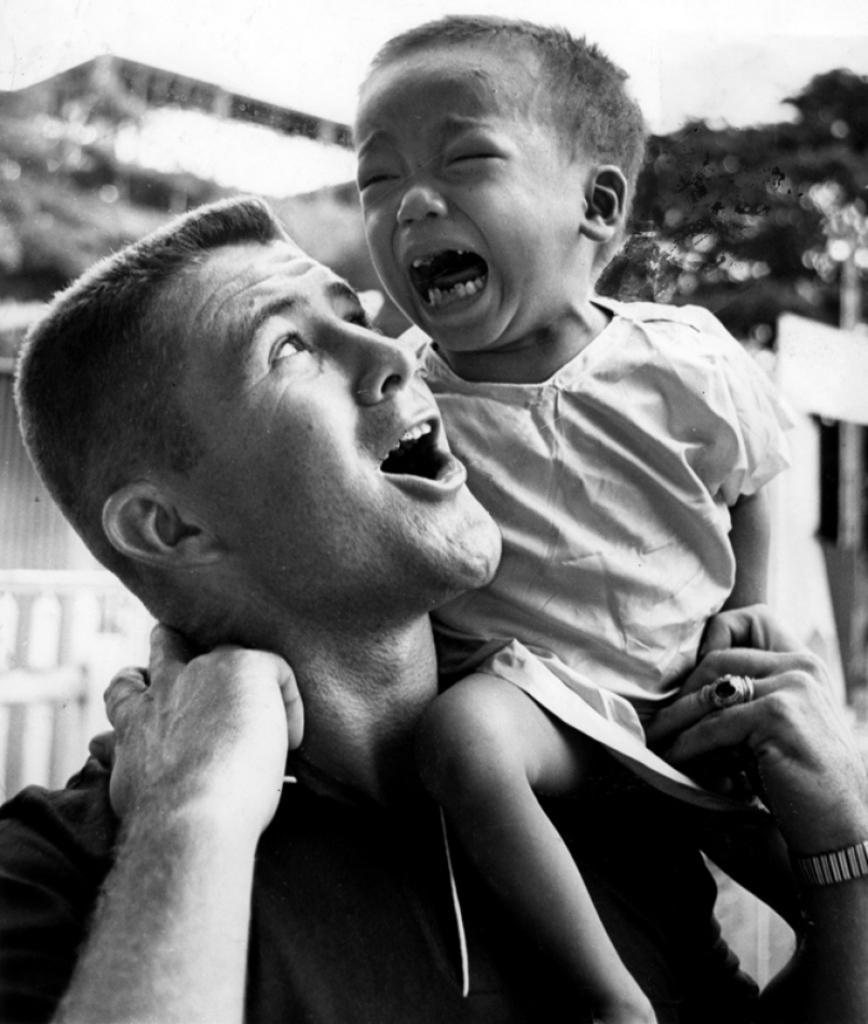In one or two sentences, can you explain what this image depicts? In this image I can see two persons. In the background I can see few trees and buildings and the image is in black and white. 